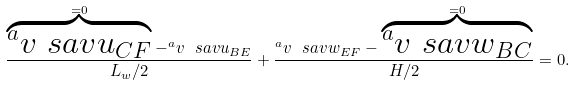Convert formula to latex. <formula><loc_0><loc_0><loc_500><loc_500>\frac { \overbrace { ^ { a } v { \ s a v { u } } _ { C F } } ^ { = 0 } - ^ { a } v { \ s a v { u } } _ { B E } } { L _ { w } / 2 } + \frac { ^ { a } v { \ s a v { w } } _ { E F } - \overbrace { ^ { a } v { \ s a v { w } } _ { B C } } ^ { = 0 } } { H / 2 } = 0 .</formula> 